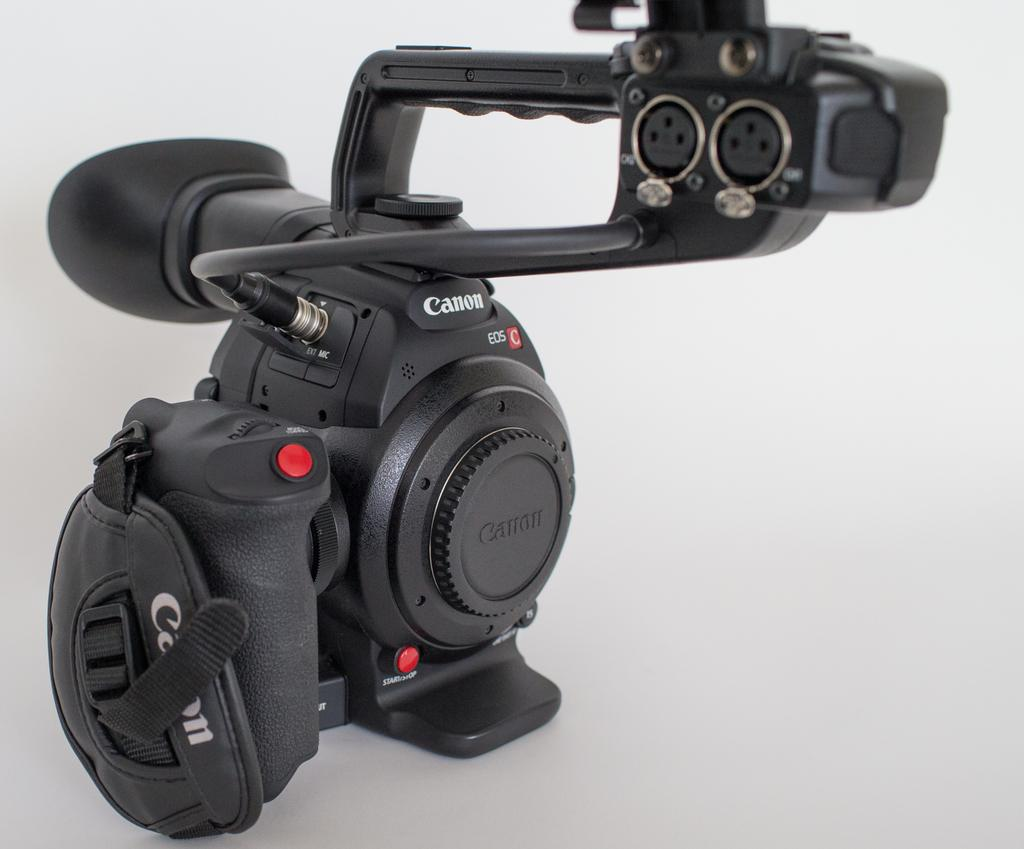What object is the main subject of the image? There is a camera in the image. What color is the camera? The camera is black in color. What color is the background of the image? The background of the image is white. How many people are visible in the image? There are no people visible in the image; it only features a black camera against a white background. What type of grain is being sorted in the image? There is no grain or sorting process depicted in the image; it only features a black camera against a white background. 